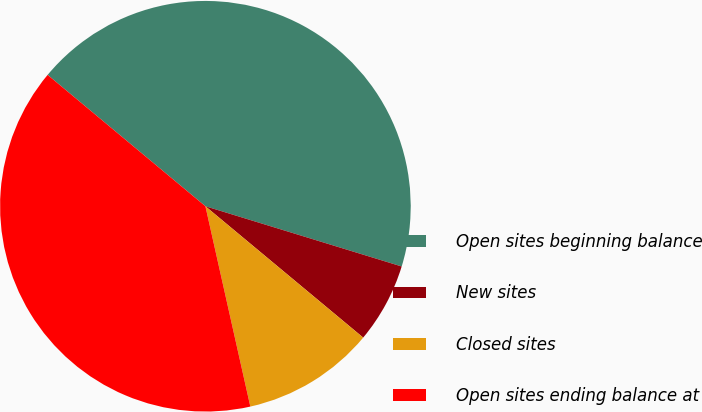Convert chart. <chart><loc_0><loc_0><loc_500><loc_500><pie_chart><fcel>Open sites beginning balance<fcel>New sites<fcel>Closed sites<fcel>Open sites ending balance at<nl><fcel>43.69%<fcel>6.31%<fcel>10.44%<fcel>39.56%<nl></chart> 